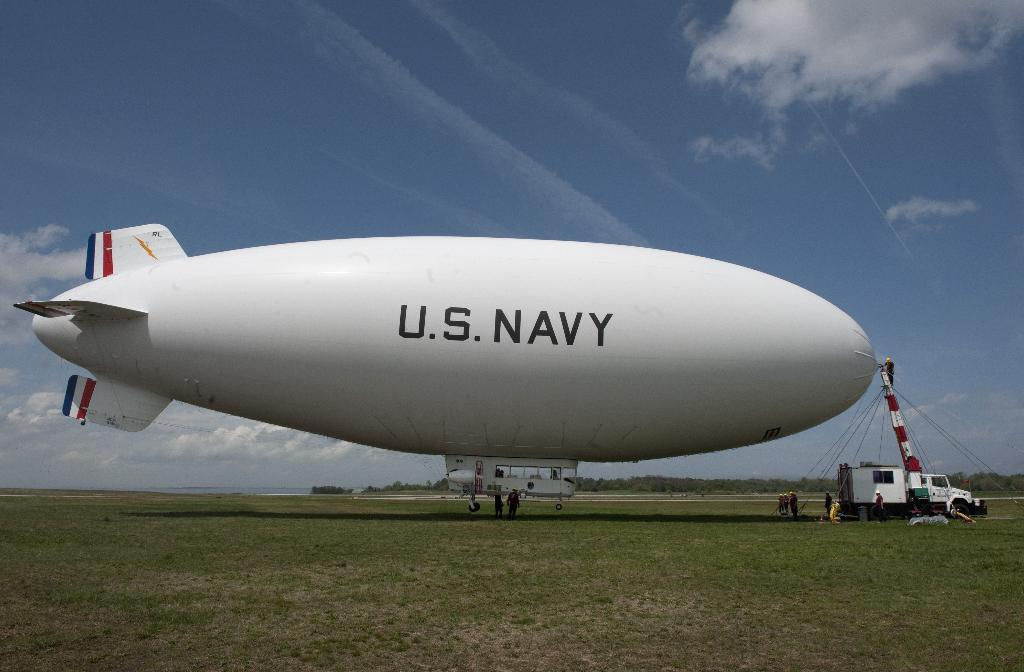<image>
Summarize the visual content of the image. A hot air blimp is being set up by the U.S. Navy in a field. 